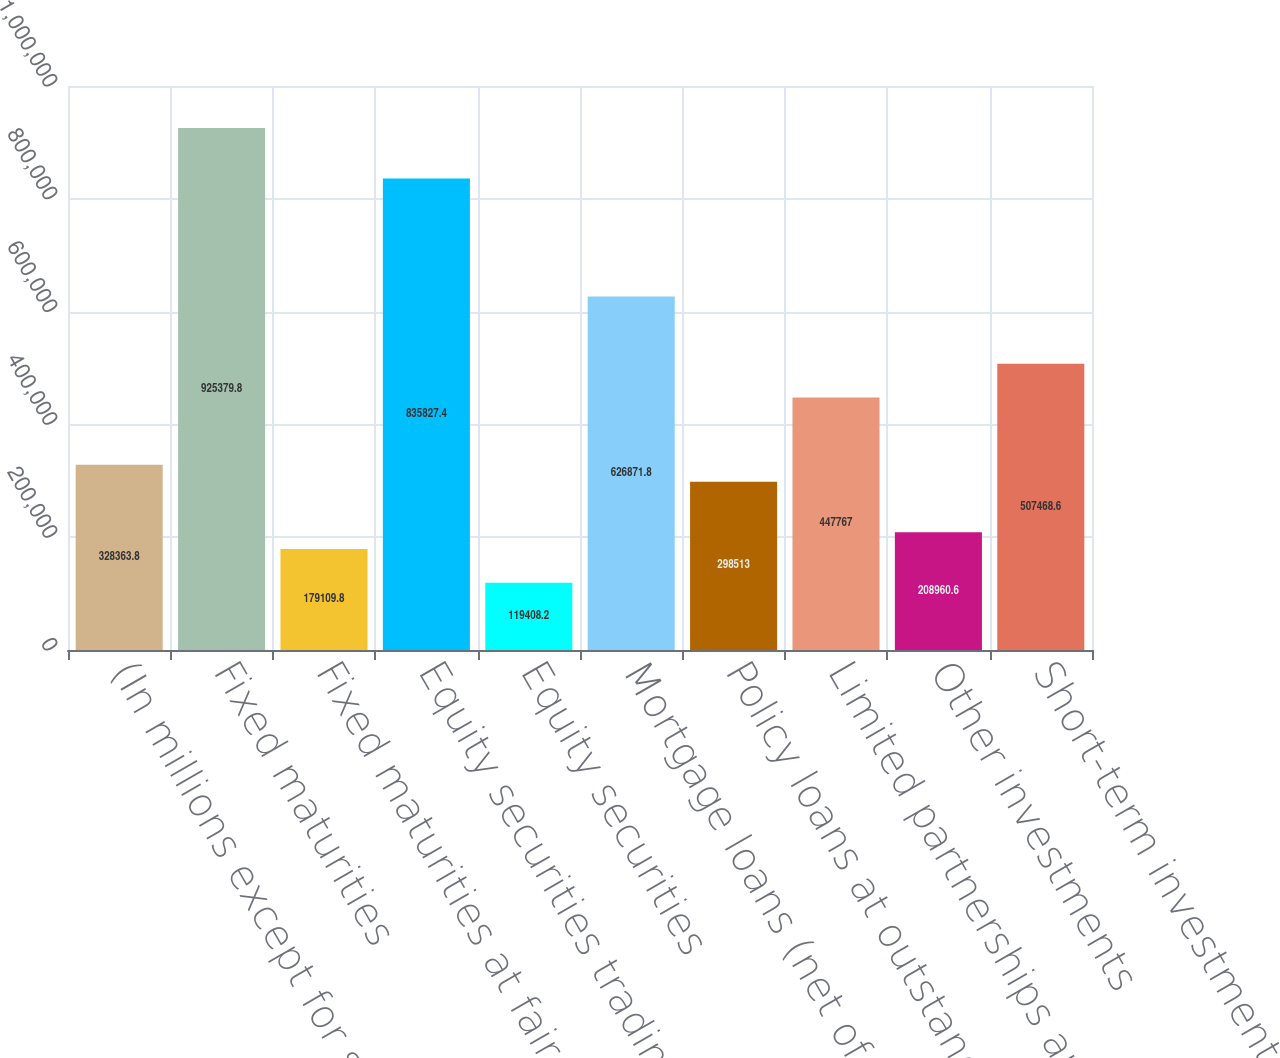Convert chart to OTSL. <chart><loc_0><loc_0><loc_500><loc_500><bar_chart><fcel>(In millions except for share<fcel>Fixed maturities<fcel>Fixed maturities at fair value<fcel>Equity securities trading at<fcel>Equity securities<fcel>Mortgage loans (net of<fcel>Policy loans at outstanding<fcel>Limited partnerships and other<fcel>Other investments<fcel>Short-term investments<nl><fcel>328364<fcel>925380<fcel>179110<fcel>835827<fcel>119408<fcel>626872<fcel>298513<fcel>447767<fcel>208961<fcel>507469<nl></chart> 